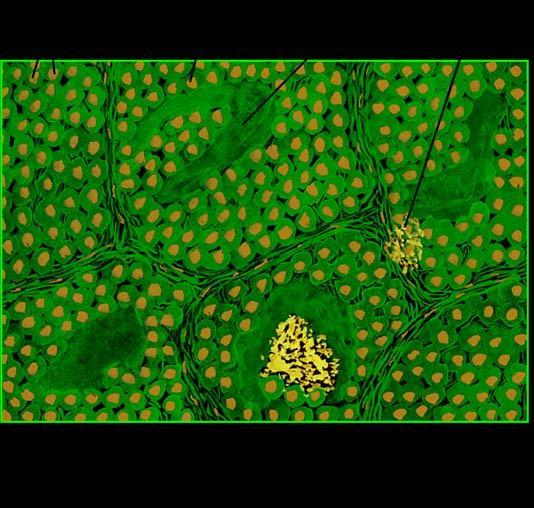what shows organoid pattern of oval tumour cells and abundant amyloid stroma?
Answer the question using a single word or phrase. Microscopy 